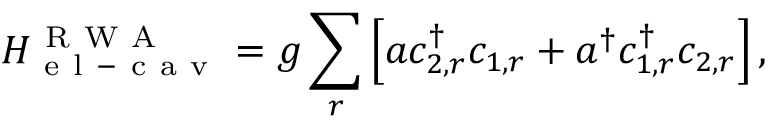<formula> <loc_0><loc_0><loc_500><loc_500>H _ { e l - c a v } ^ { R W A } = g \sum _ { r } \left [ a c _ { 2 , r } ^ { \dagger } c _ { 1 , r } + a ^ { \dagger } c _ { 1 , r } ^ { \dagger } c _ { 2 , r } \right ] ,</formula> 